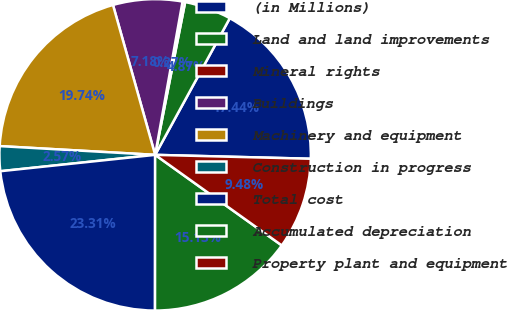Convert chart to OTSL. <chart><loc_0><loc_0><loc_500><loc_500><pie_chart><fcel>(in Millions)<fcel>Land and land improvements<fcel>Mineral rights<fcel>Buildings<fcel>Machinery and equipment<fcel>Construction in progress<fcel>Total cost<fcel>Accumulated depreciation<fcel>Property plant and equipment<nl><fcel>17.44%<fcel>4.87%<fcel>0.27%<fcel>7.18%<fcel>19.74%<fcel>2.57%<fcel>23.31%<fcel>15.13%<fcel>9.48%<nl></chart> 